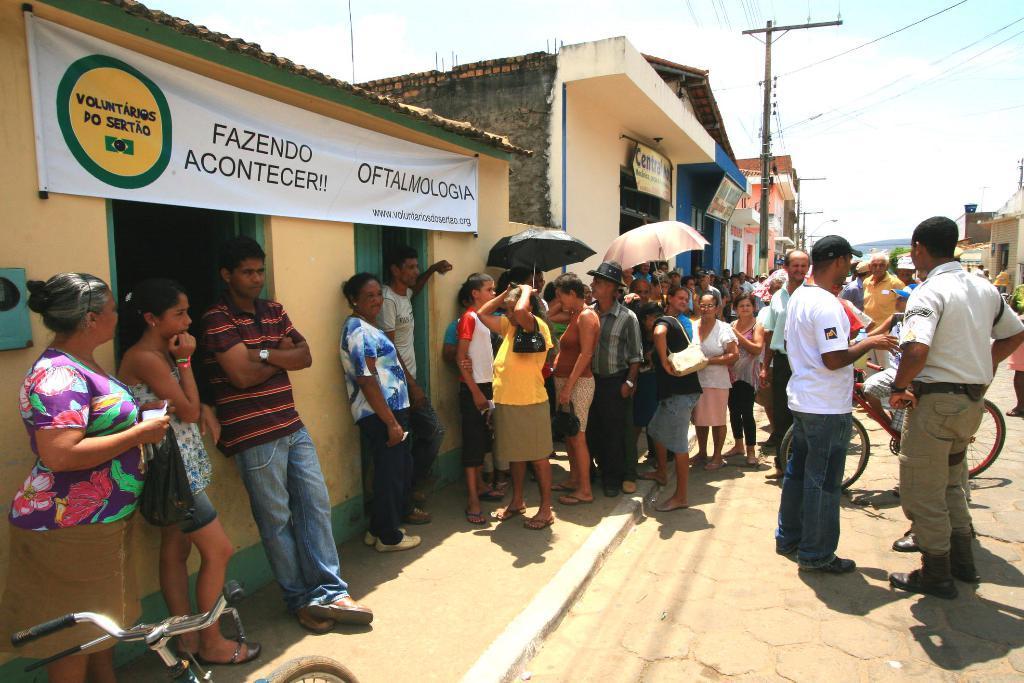Please provide a concise description of this image. There are many people standing outside the house, some of them are holding umbrella and in front of the house there is a banner and beside that house there are many other houses they are also having banners in the front. There are two current poles and many wires are attached to the poles. 